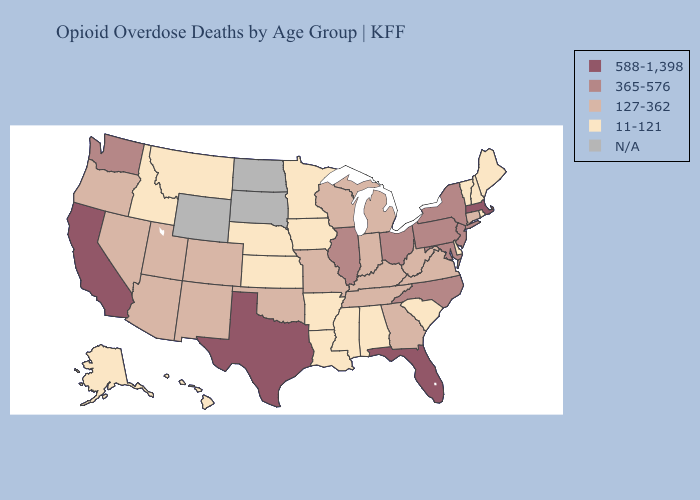How many symbols are there in the legend?
Quick response, please. 5. Among the states that border Alabama , does Mississippi have the lowest value?
Answer briefly. Yes. What is the value of Michigan?
Quick response, please. 127-362. What is the lowest value in the USA?
Concise answer only. 11-121. Does Iowa have the lowest value in the MidWest?
Give a very brief answer. Yes. What is the value of New York?
Be succinct. 365-576. Name the states that have a value in the range 11-121?
Quick response, please. Alabama, Alaska, Arkansas, Delaware, Hawaii, Idaho, Iowa, Kansas, Louisiana, Maine, Minnesota, Mississippi, Montana, Nebraska, New Hampshire, Rhode Island, South Carolina, Vermont. What is the value of North Dakota?
Keep it brief. N/A. Name the states that have a value in the range 11-121?
Be succinct. Alabama, Alaska, Arkansas, Delaware, Hawaii, Idaho, Iowa, Kansas, Louisiana, Maine, Minnesota, Mississippi, Montana, Nebraska, New Hampshire, Rhode Island, South Carolina, Vermont. Name the states that have a value in the range 11-121?
Answer briefly. Alabama, Alaska, Arkansas, Delaware, Hawaii, Idaho, Iowa, Kansas, Louisiana, Maine, Minnesota, Mississippi, Montana, Nebraska, New Hampshire, Rhode Island, South Carolina, Vermont. Does Alabama have the lowest value in the USA?
Write a very short answer. Yes. 